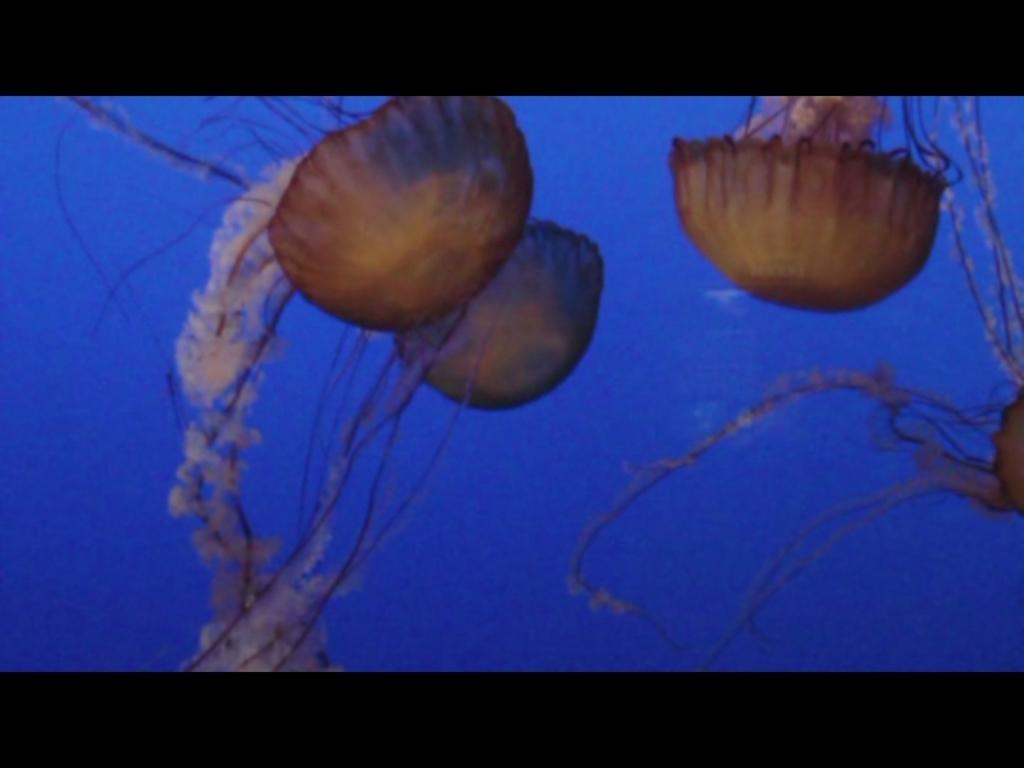Describe this image in one or two sentences. In this image there are a few jellyfishes in the water. 